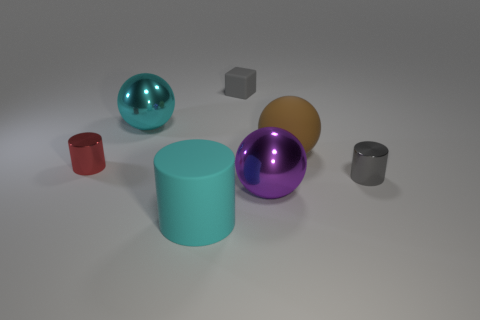Are there any other things that have the same shape as the gray rubber thing? Yes, the cylindrical shape of the gray object in the image is shared by several other objects in different sizes and colors; notably, there's a blue-green reflective sphere that mirrors the shape of the small, gray cube. 